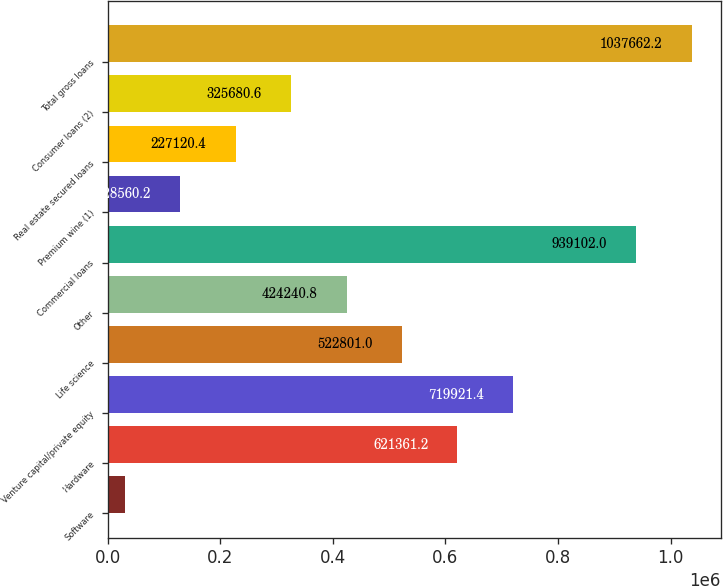Convert chart to OTSL. <chart><loc_0><loc_0><loc_500><loc_500><bar_chart><fcel>Software<fcel>Hardware<fcel>Venture capital/private equity<fcel>Life science<fcel>Other<fcel>Commercial loans<fcel>Premium wine (1)<fcel>Real estate secured loans<fcel>Consumer loans (2)<fcel>Total gross loans<nl><fcel>30000<fcel>621361<fcel>719921<fcel>522801<fcel>424241<fcel>939102<fcel>128560<fcel>227120<fcel>325681<fcel>1.03766e+06<nl></chart> 